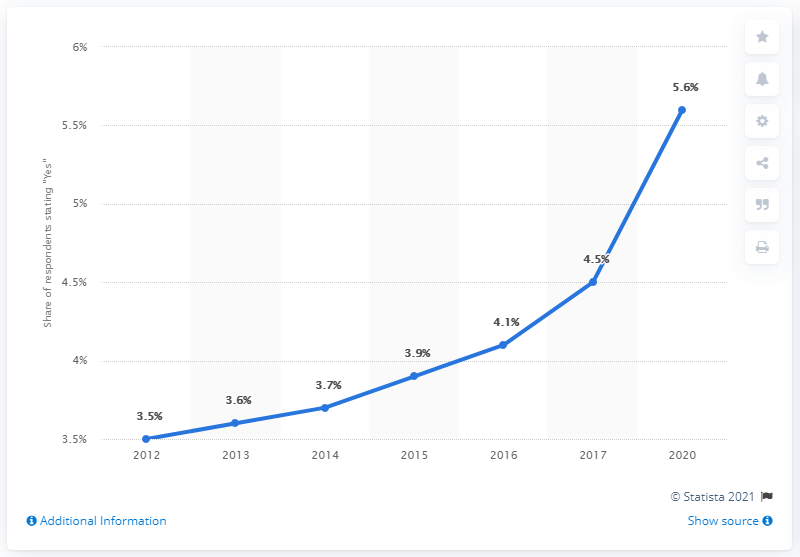Highlight a few significant elements in this photo. In 2012, approximately 3.5% of adults identified as LGBT. In the year 2020, 5.6% of adults identified as lesbian, gay, bisexual, or transgender. 